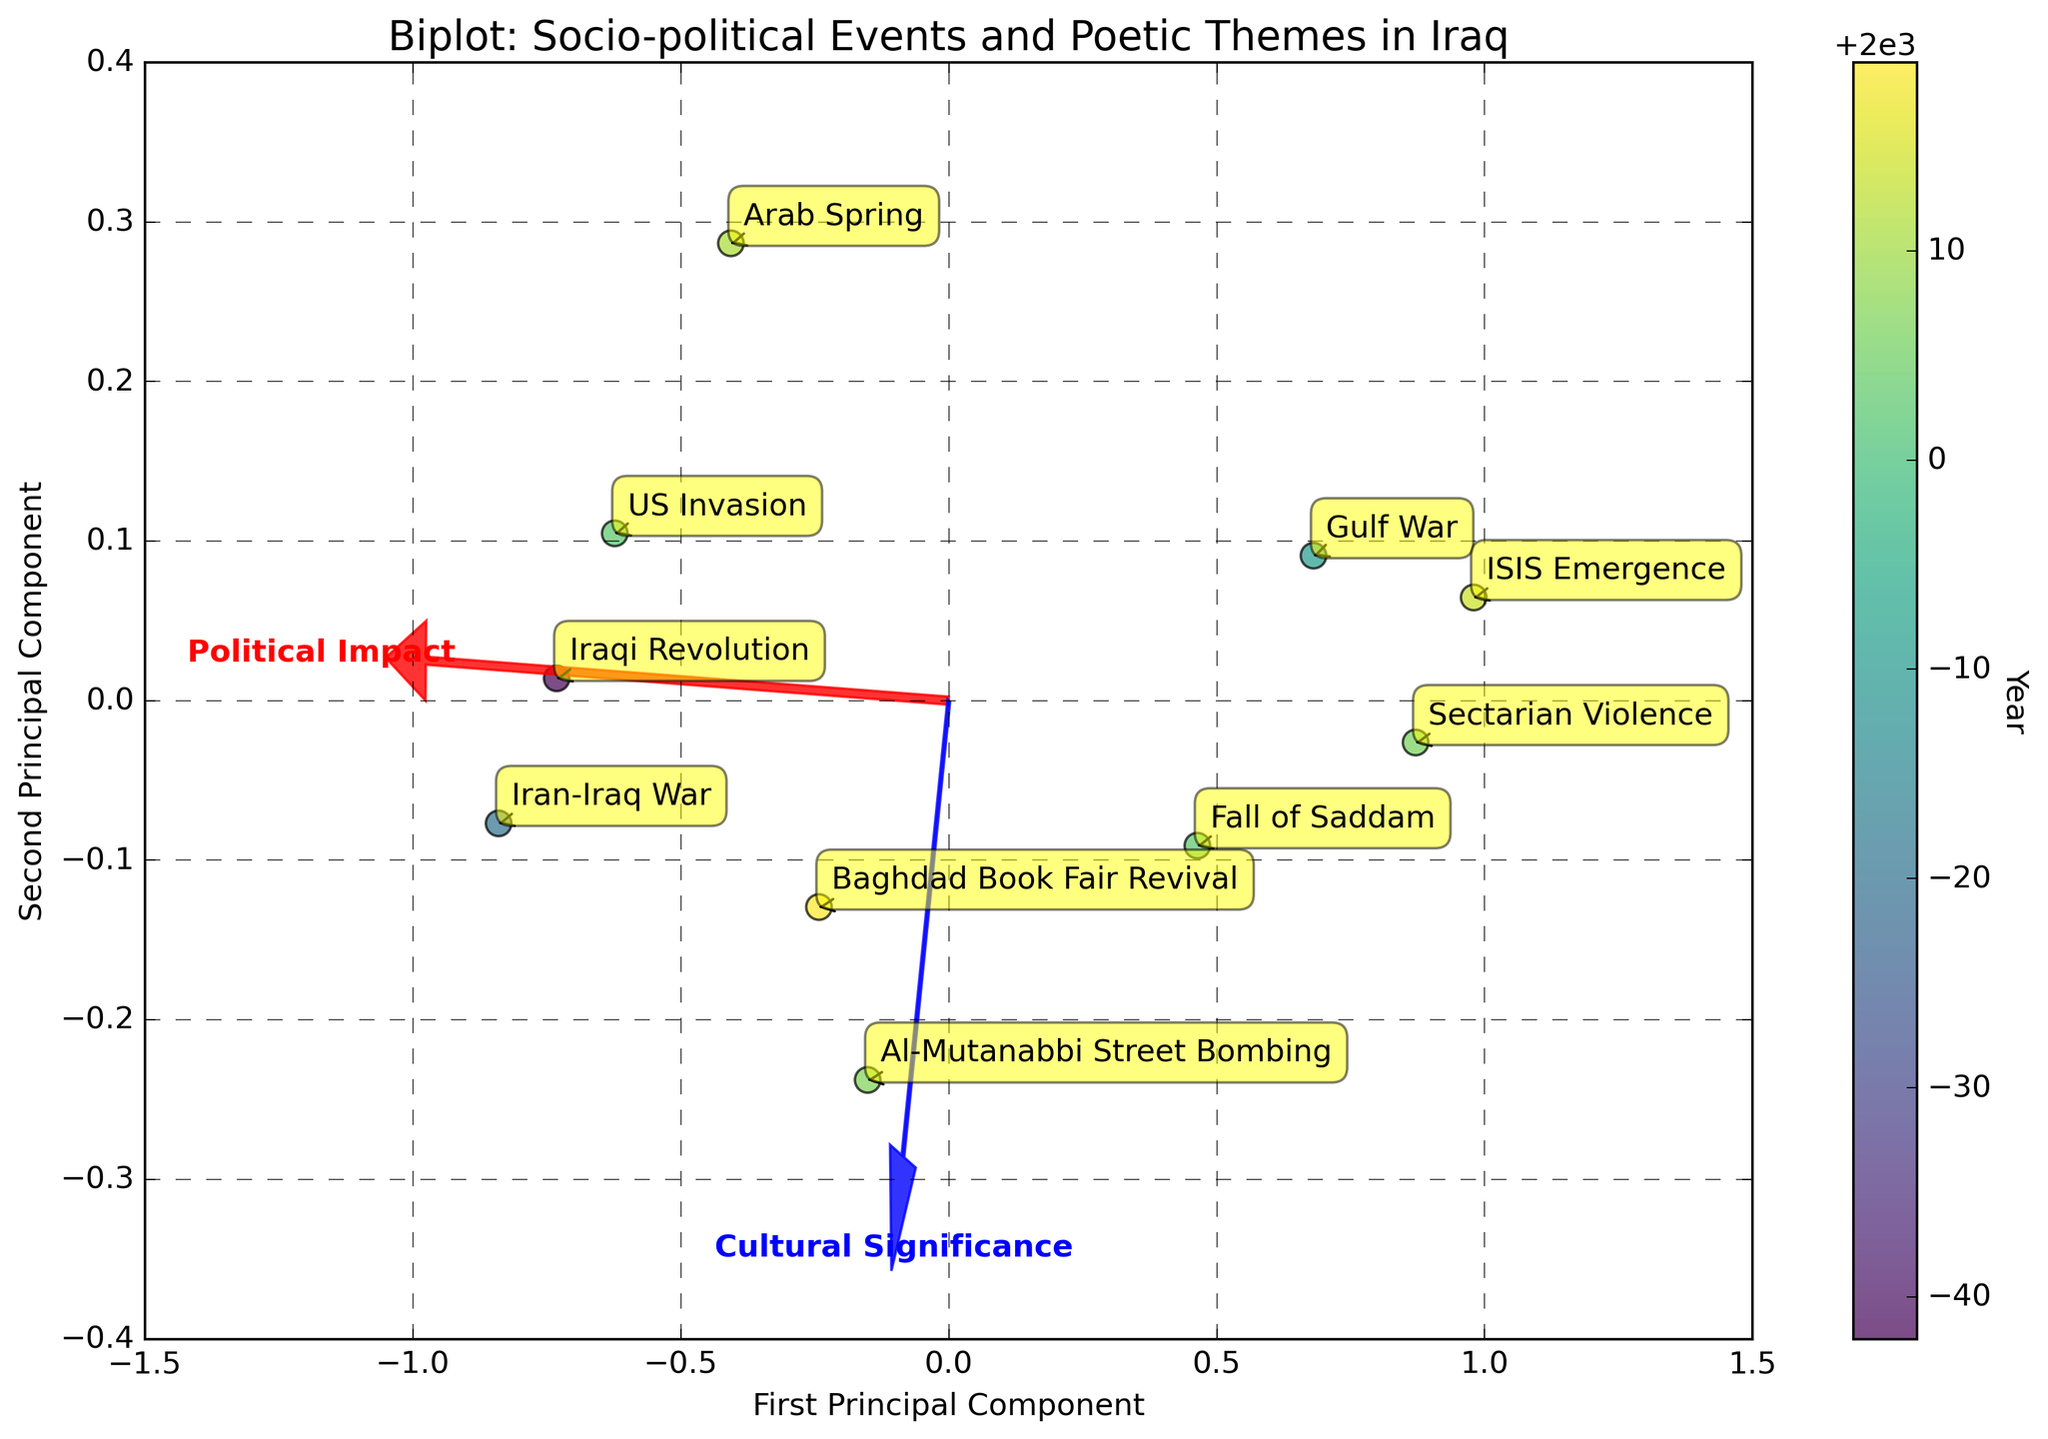What is the title of the biplot? The title of the biplot can be found at the top of the figure where it is generally placed.
Answer: Biplot: Socio-political Events and Poetic Themes in Iraq How many events are depicted in the biplot? This can be determined by counting the number of points or annotations present in the plot.
Answer: 10 Which event is located at the highest point along the first principal component? To find this, look at the point that has the maximum coordinate value on the x-axis.
Answer: Iran-Iraq War Which feature vector (Political Impact or Cultural Significance) has a stronger influence along the first principal component? By examining the directions and lengths of the arrows representing the feature vectors, one can see which arrow extends further in the direction of the first principal component.
Answer: Political Impact Are there more events before or after the US Invasion in 2003? By looking at the color gradient representing the years, determine which side of the color gradient has more events.
Answer: After the US Invasion What is the direction of the feature vector for Cultural Significance? This can be observed by noting the angle and direction of the arrow labeled "Cultural Significance".
Answer: Positively along the second principal component and negatively along the first principal component Compare the distances between the events "Fall of Saddam" and "Baghdad Book Fair Revival" to the origin. Which is closer? By looking at the locations of these two points relative to the origin, one can determine which point is closer.
Answer: Baghdad Book Fair Revival What is the relationship between the event "ISIS Emergence" and the Cultural Significance axis? Analyze the position of the "ISIS Emergence" point concerning the direction of the arrow for Cultural Significance.
Answer: Very little positive correlation Which event shows the weakest Political Impact but highest Cultural Significance? The point that is closest to zero on the Political Impact vector but highest along the Cultural Significance vector will answer this.
Answer: Al-Mutanabbi Street Bombing 